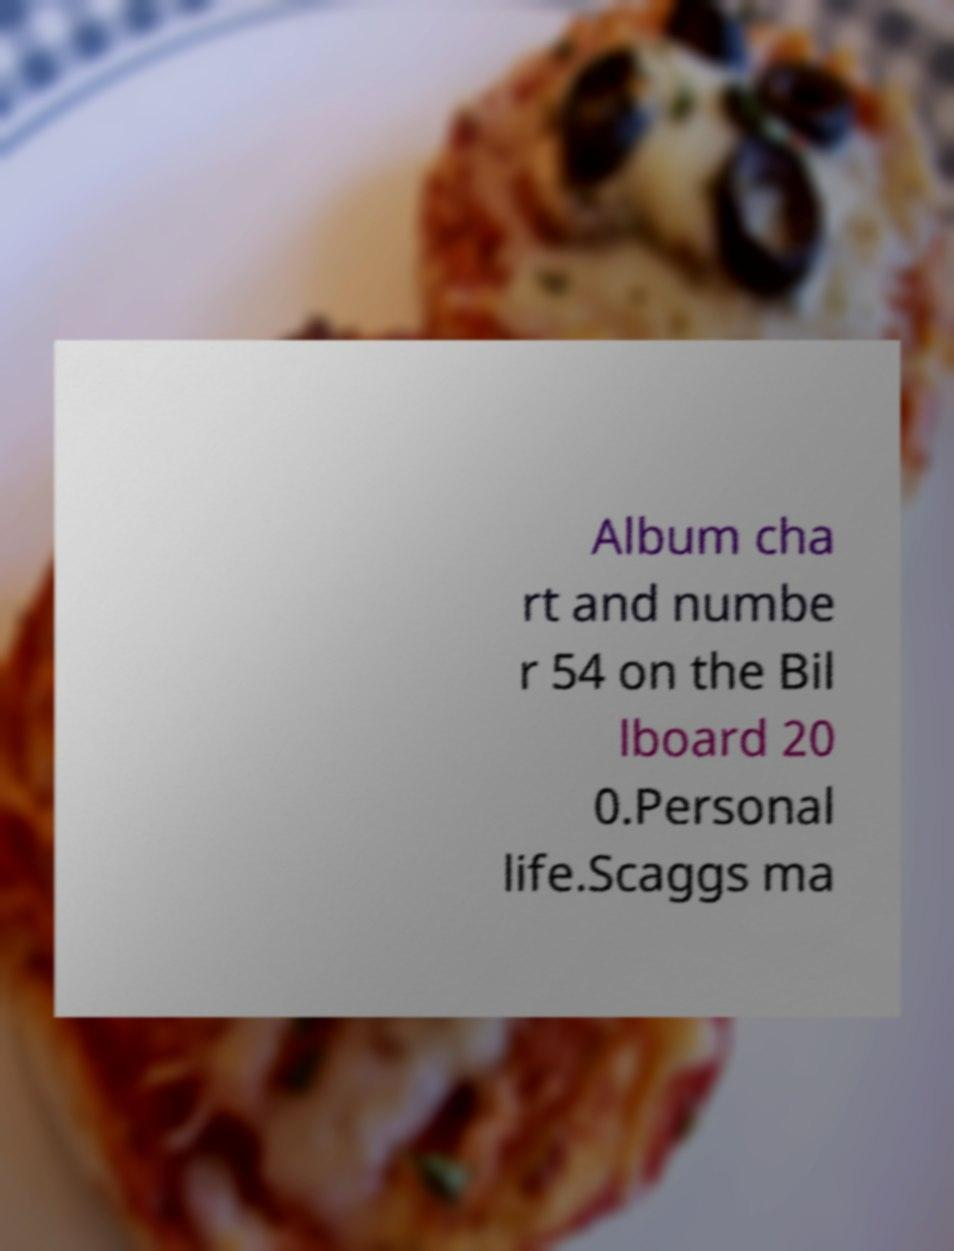Can you accurately transcribe the text from the provided image for me? Album cha rt and numbe r 54 on the Bil lboard 20 0.Personal life.Scaggs ma 